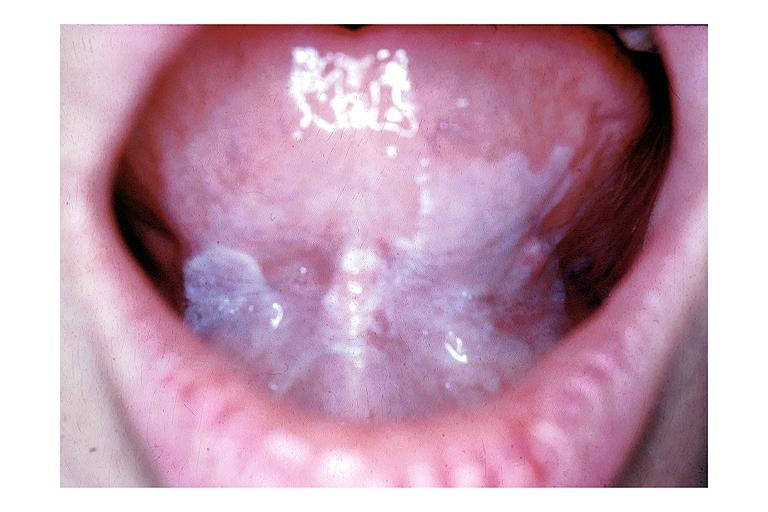does oil acid show leukoplakia?
Answer the question using a single word or phrase. No 